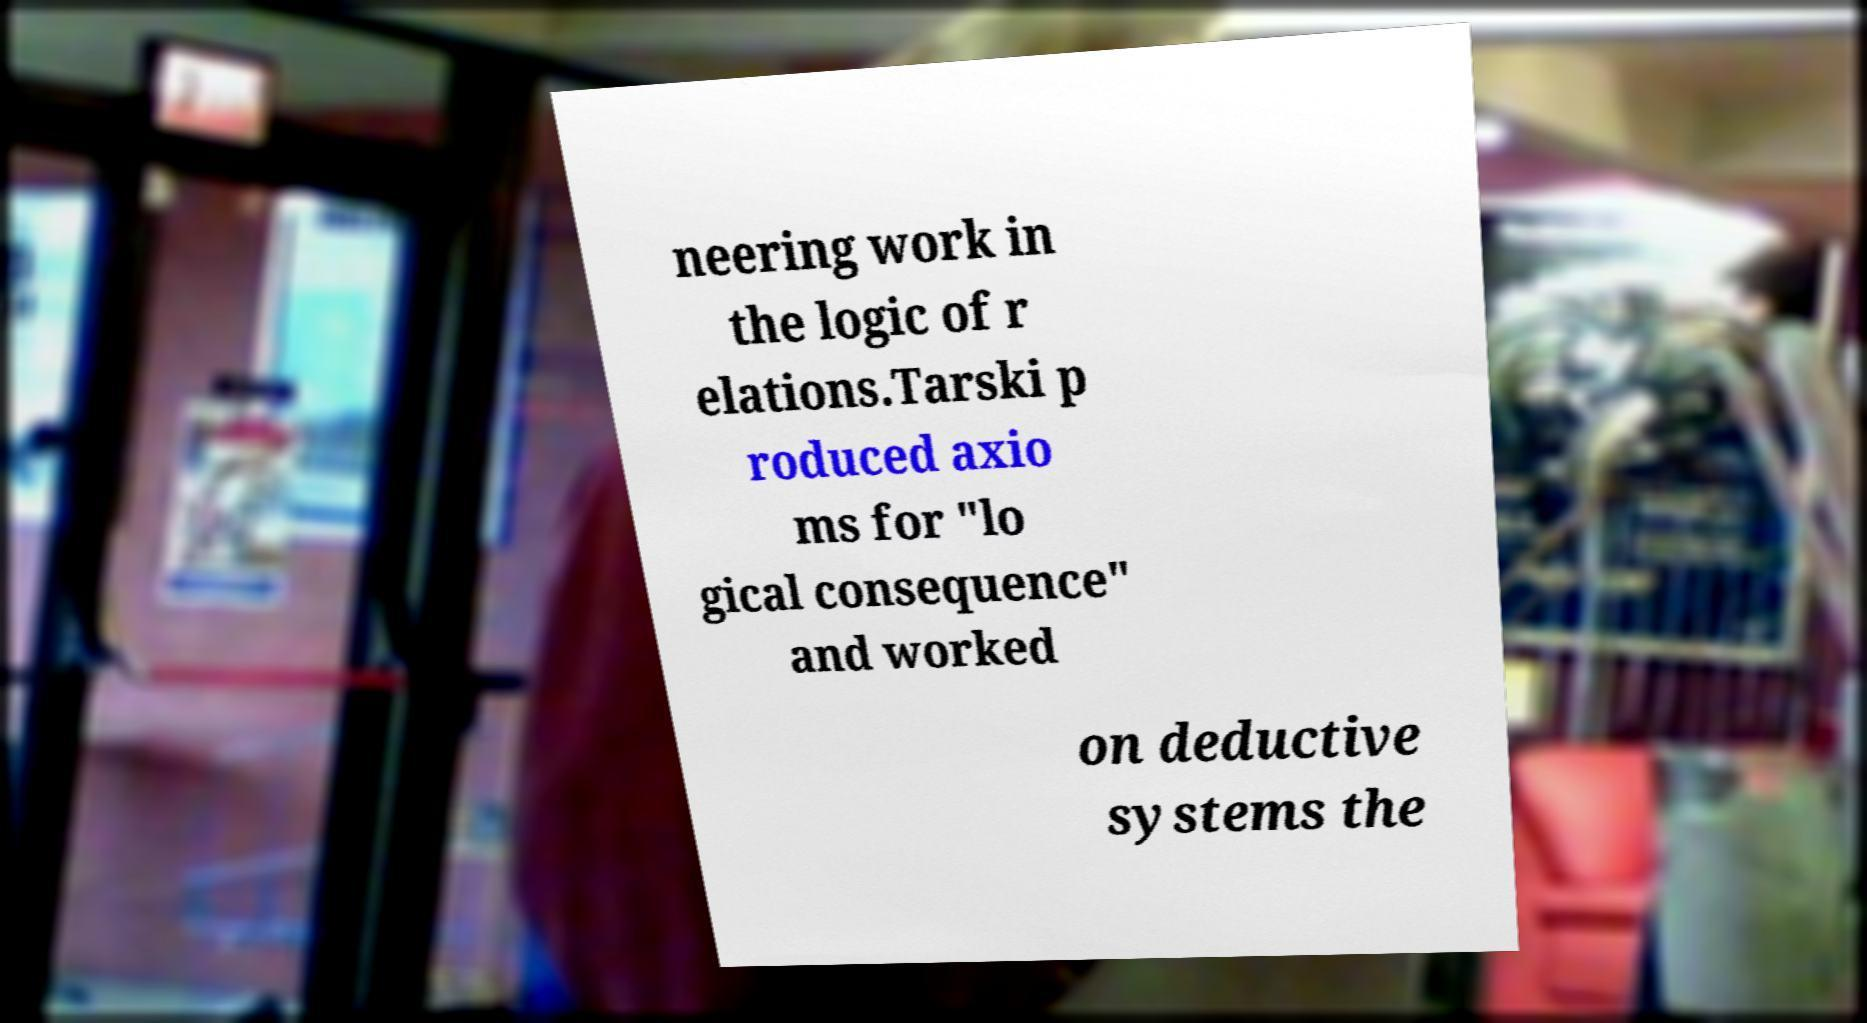Could you extract and type out the text from this image? neering work in the logic of r elations.Tarski p roduced axio ms for "lo gical consequence" and worked on deductive systems the 